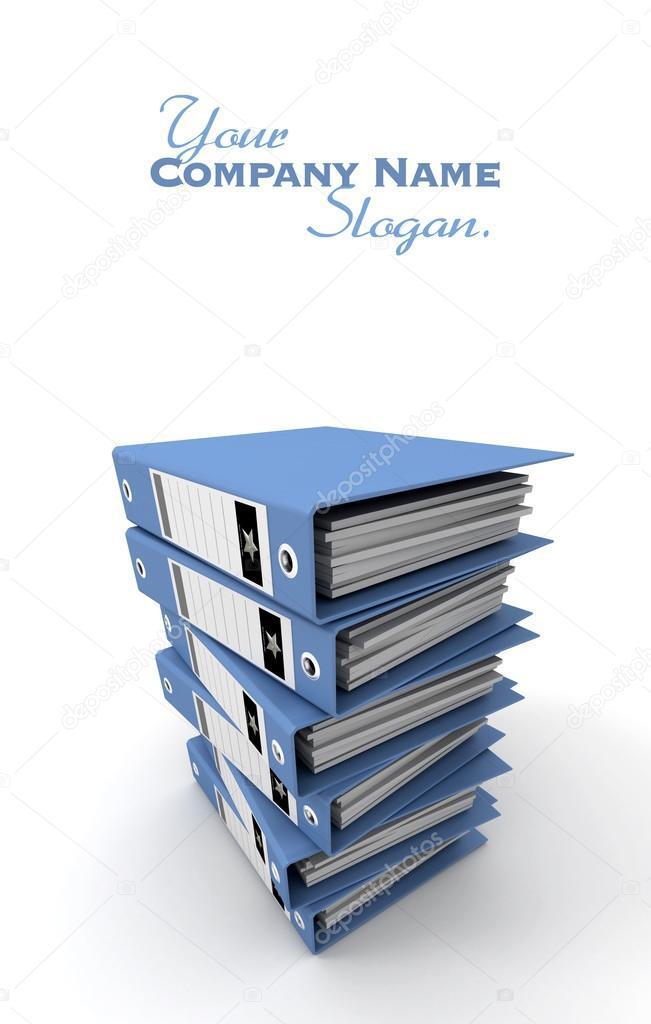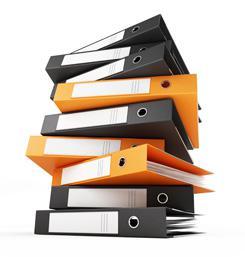The first image is the image on the left, the second image is the image on the right. For the images shown, is this caption "There is two stacks of binders in the center of the images." true? Answer yes or no. Yes. 